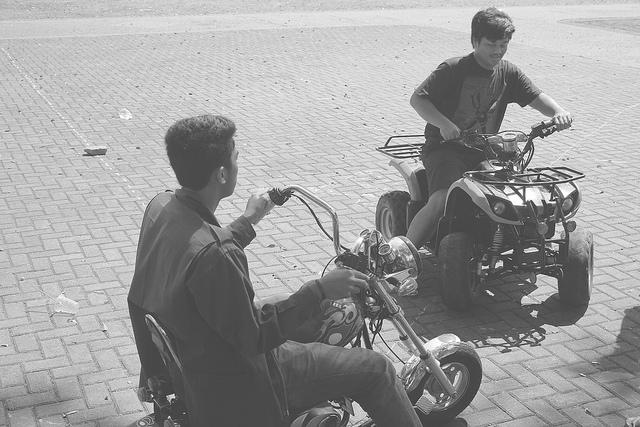Where are these men riding?

Choices:
A) mountain
B) beach
C) woods
D) street street 